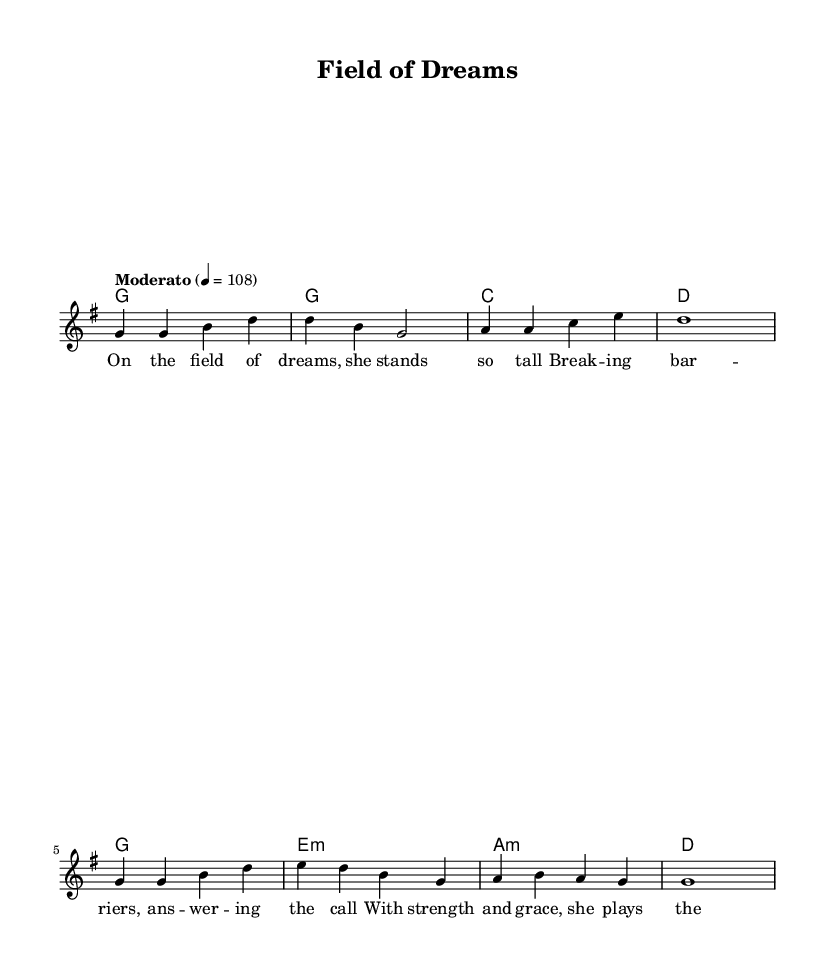What is the key signature of this music? The key signature is G major, which has one sharp (F#) indicated at the beginning of the staff.
Answer: G major What is the time signature of this music? The time signature is 4/4, which means there are four beats in each measure and the quarter note gets one beat.
Answer: 4/4 What is the tempo marking for this piece? The tempo marking is set to "Moderato," which indicates a moderate speed, typically around 108 beats per minute, as shown in the music.
Answer: Moderato How many measures are in the melody section? The melody section consists of 8 measures as indicated by the grouping of notes and rests in the sheet music.
Answer: 8 measures What is the structure of the song's verse? The structure of the song's verse follows a four-line pattern, with each line corresponding to specific phrases of the lyrics that capture the theme of women's empowerment in sports.
Answer: Four lines What type of harmony is used in the piece? The harmonies are based on the chord progression typical of folk music, featuring major and minor chords that complement the melody and lyrics.
Answer: Major and minor chords What overall theme does the song represent? The overall theme of the song celebrates women in athletics and their achievements in breaking gender barriers, as reflected in the lyrics and title.
Answer: Women athletes 